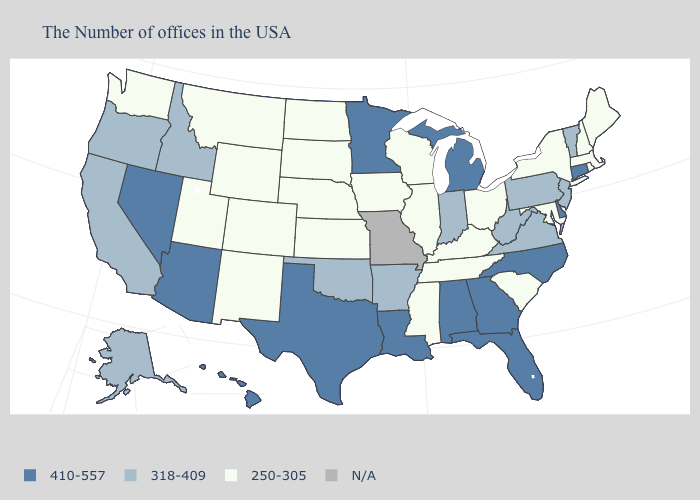Does Kentucky have the lowest value in the South?
Keep it brief. Yes. What is the value of Florida?
Write a very short answer. 410-557. What is the highest value in the USA?
Concise answer only. 410-557. Name the states that have a value in the range 318-409?
Concise answer only. Vermont, New Jersey, Pennsylvania, Virginia, West Virginia, Indiana, Arkansas, Oklahoma, Idaho, California, Oregon, Alaska. Does the map have missing data?
Give a very brief answer. Yes. What is the highest value in the USA?
Be succinct. 410-557. How many symbols are there in the legend?
Concise answer only. 4. Name the states that have a value in the range 250-305?
Answer briefly. Maine, Massachusetts, Rhode Island, New Hampshire, New York, Maryland, South Carolina, Ohio, Kentucky, Tennessee, Wisconsin, Illinois, Mississippi, Iowa, Kansas, Nebraska, South Dakota, North Dakota, Wyoming, Colorado, New Mexico, Utah, Montana, Washington. Among the states that border California , which have the highest value?
Give a very brief answer. Arizona, Nevada. What is the lowest value in the USA?
Write a very short answer. 250-305. Does Maryland have the lowest value in the South?
Concise answer only. Yes. What is the value of Wyoming?
Concise answer only. 250-305. Among the states that border Indiana , which have the lowest value?
Be succinct. Ohio, Kentucky, Illinois. Name the states that have a value in the range 318-409?
Keep it brief. Vermont, New Jersey, Pennsylvania, Virginia, West Virginia, Indiana, Arkansas, Oklahoma, Idaho, California, Oregon, Alaska. Among the states that border Connecticut , which have the highest value?
Write a very short answer. Massachusetts, Rhode Island, New York. 